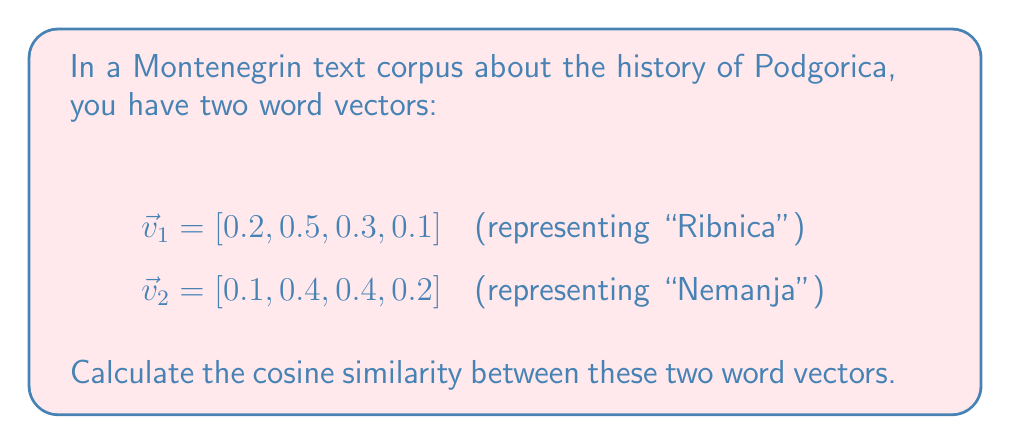What is the answer to this math problem? To calculate the cosine similarity between two word vectors, we use the formula:

$$\text{cosine similarity} = \frac{\vec{v}_1 \cdot \vec{v}_2}{\|\vec{v}_1\| \|\vec{v}_2\|}$$

Step 1: Calculate the dot product $\vec{v}_1 \cdot \vec{v}_2$
$$\vec{v}_1 \cdot \vec{v}_2 = (0.2 \times 0.1) + (0.5 \times 0.4) + (0.3 \times 0.4) + (0.1 \times 0.2)$$
$$\vec{v}_1 \cdot \vec{v}_2 = 0.02 + 0.20 + 0.12 + 0.02 = 0.36$$

Step 2: Calculate the magnitudes $\|\vec{v}_1\|$ and $\|\vec{v}_2\|$
$$\|\vec{v}_1\| = \sqrt{0.2^2 + 0.5^2 + 0.3^2 + 0.1^2} = \sqrt{0.04 + 0.25 + 0.09 + 0.01} = \sqrt{0.39} \approx 0.6245$$
$$\|\vec{v}_2\| = \sqrt{0.1^2 + 0.4^2 + 0.4^2 + 0.2^2} = \sqrt{0.01 + 0.16 + 0.16 + 0.04} = \sqrt{0.37} \approx 0.6083$$

Step 3: Apply the cosine similarity formula
$$\text{cosine similarity} = \frac{0.36}{0.6245 \times 0.6083} \approx 0.9463$$
Answer: 0.9463 